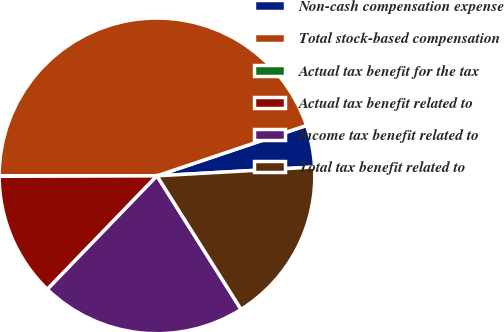<chart> <loc_0><loc_0><loc_500><loc_500><pie_chart><fcel>Non-cash compensation expense<fcel>Total stock-based compensation<fcel>Actual tax benefit for the tax<fcel>Actual tax benefit related to<fcel>Income tax benefit related to<fcel>Total tax benefit related to<nl><fcel>4.28%<fcel>44.82%<fcel>0.05%<fcel>12.73%<fcel>21.17%<fcel>16.95%<nl></chart> 